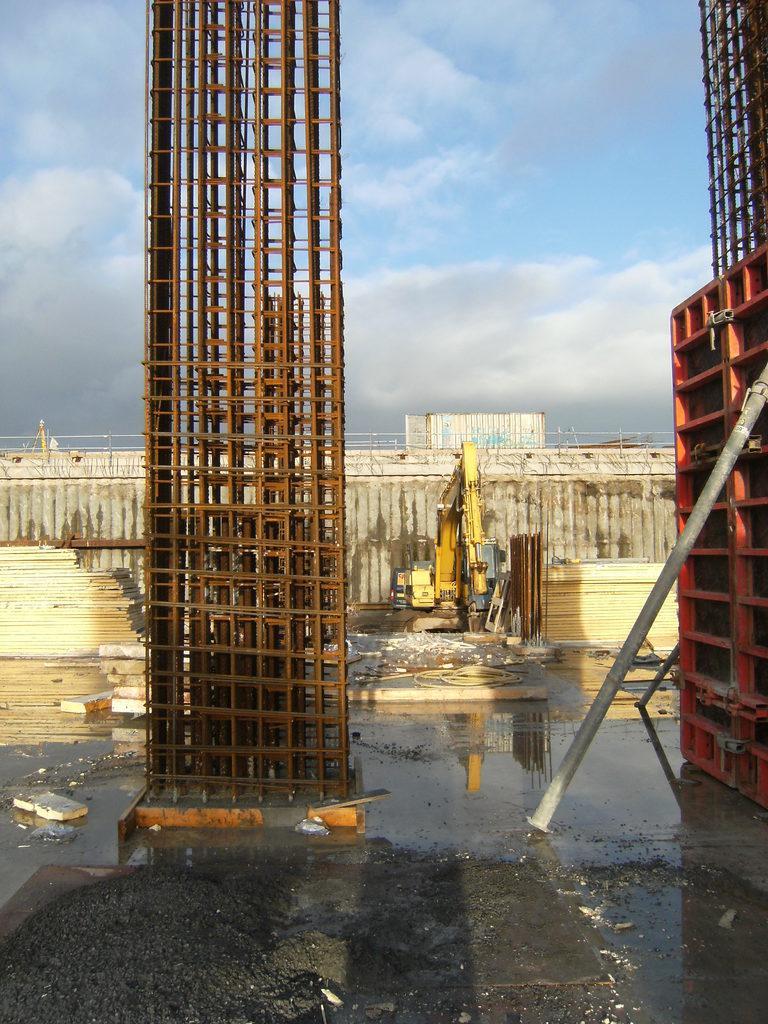Describe this image in one or two sentences. In this image I see an iron pillar and water over here. In the background a vehicle which is of yellow in color, a fence and the sky. 